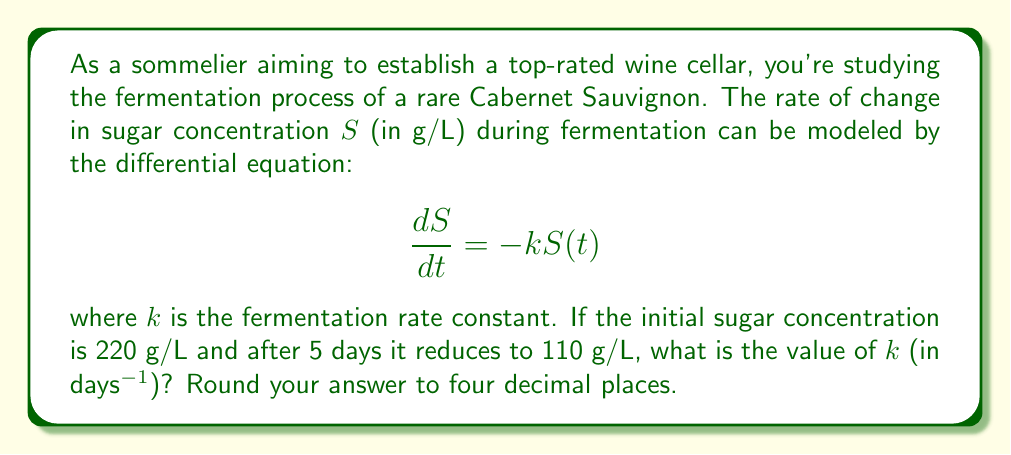Show me your answer to this math problem. Let's solve this step-by-step:

1) The given differential equation is a first-order linear differential equation:
   $$\frac{dS}{dt} = -kS(t)$$

2) The solution to this equation is:
   $$S(t) = S_0e^{-kt}$$
   where $S_0$ is the initial sugar concentration.

3) We're given:
   - $S_0 = 220$ g/L
   - After 5 days, $S(5) = 110$ g/L

4) Let's substitute these values into our solution:
   $$110 = 220e^{-5k}$$

5) Divide both sides by 220:
   $$\frac{1}{2} = e^{-5k}$$

6) Take the natural logarithm of both sides:
   $$\ln(\frac{1}{2}) = -5k$$

7) Solve for $k$:
   $$k = -\frac{\ln(\frac{1}{2})}{5} = \frac{\ln(2)}{5}$$

8) Calculate and round to four decimal places:
   $$k \approx 0.1386\text{ days}^{-1}$$
Answer: 0.1386 days$^{-1}$ 